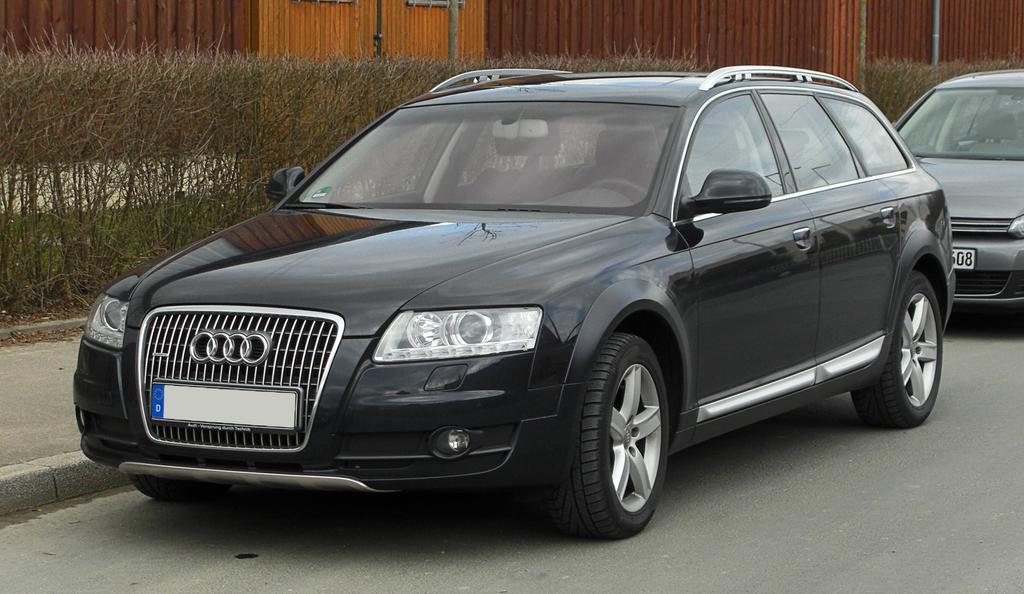Could you give a brief overview of what you see in this image? This picture is clicked outside. In the center we can see the two cars parked on the ground. In the background we can see the the objects seems to be the walls of the building and we can see the poles and dry stems. 